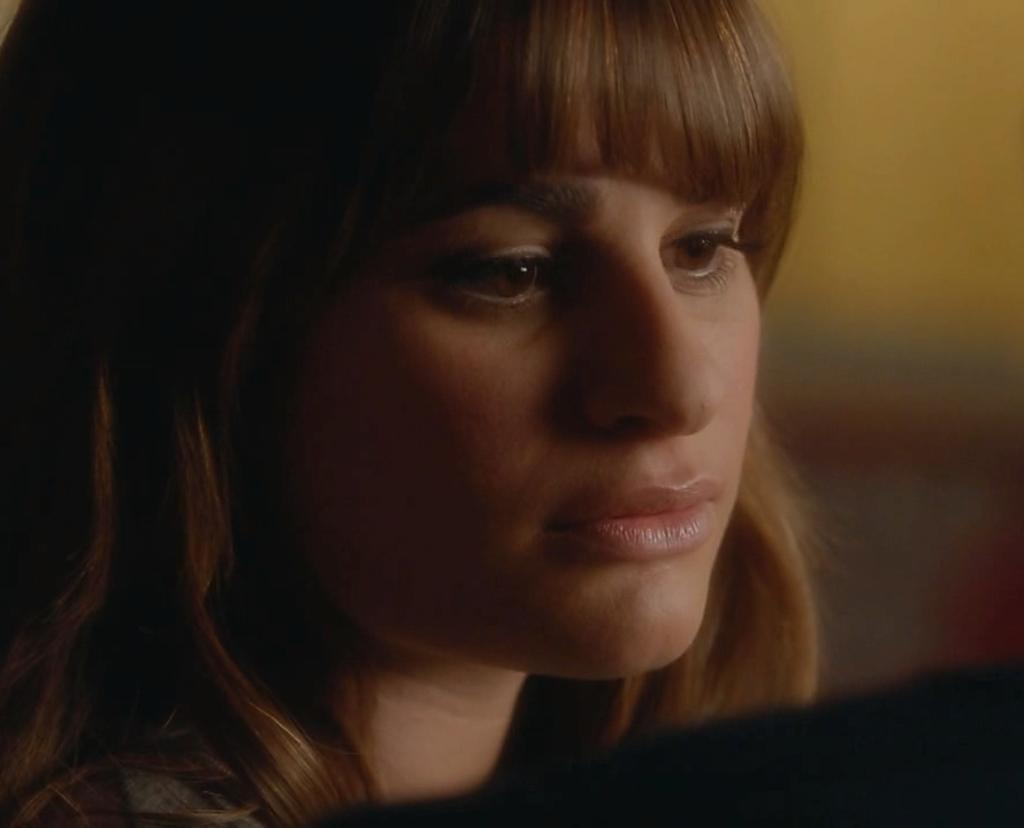What is the main subject of the image? The main subject of the image is a woman. What is the woman doing in the image? The woman is watching something. Can you describe the background of the image? The background of the image is blurred. How many brothers does the woman have in the image? There is no information about the woman's brothers in the image. What type of minister is present in the image? There is no minister present in the image. 